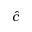Convert formula to latex. <formula><loc_0><loc_0><loc_500><loc_500>\hat { c }</formula> 